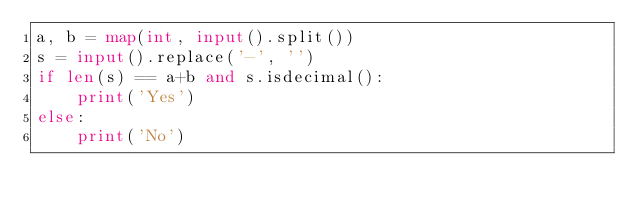Convert code to text. <code><loc_0><loc_0><loc_500><loc_500><_Python_>a, b = map(int, input().split())
s = input().replace('-', '')
if len(s) == a+b and s.isdecimal():
    print('Yes')
else:
    print('No')
</code> 